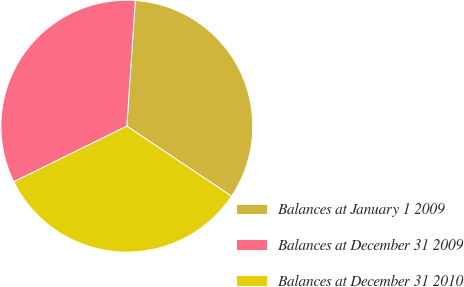Convert chart to OTSL. <chart><loc_0><loc_0><loc_500><loc_500><pie_chart><fcel>Balances at January 1 2009<fcel>Balances at December 31 2009<fcel>Balances at December 31 2010<nl><fcel>33.31%<fcel>33.33%<fcel>33.35%<nl></chart> 